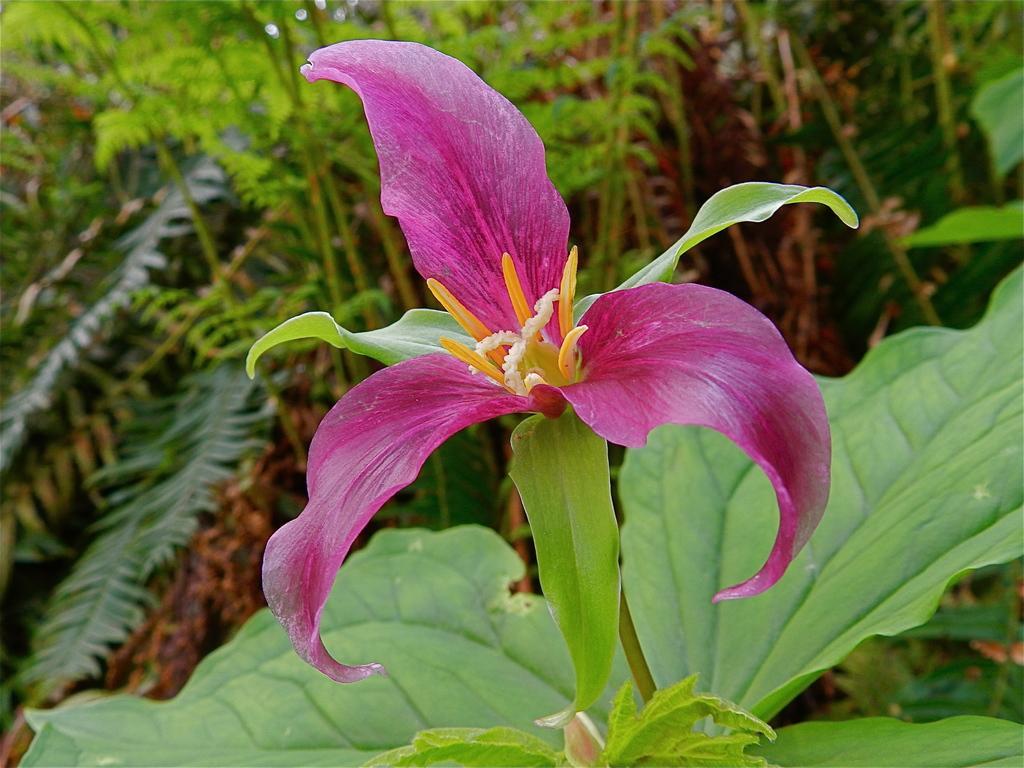Can you describe this image briefly? In this image there is a flower to the stem and there are few plants. 